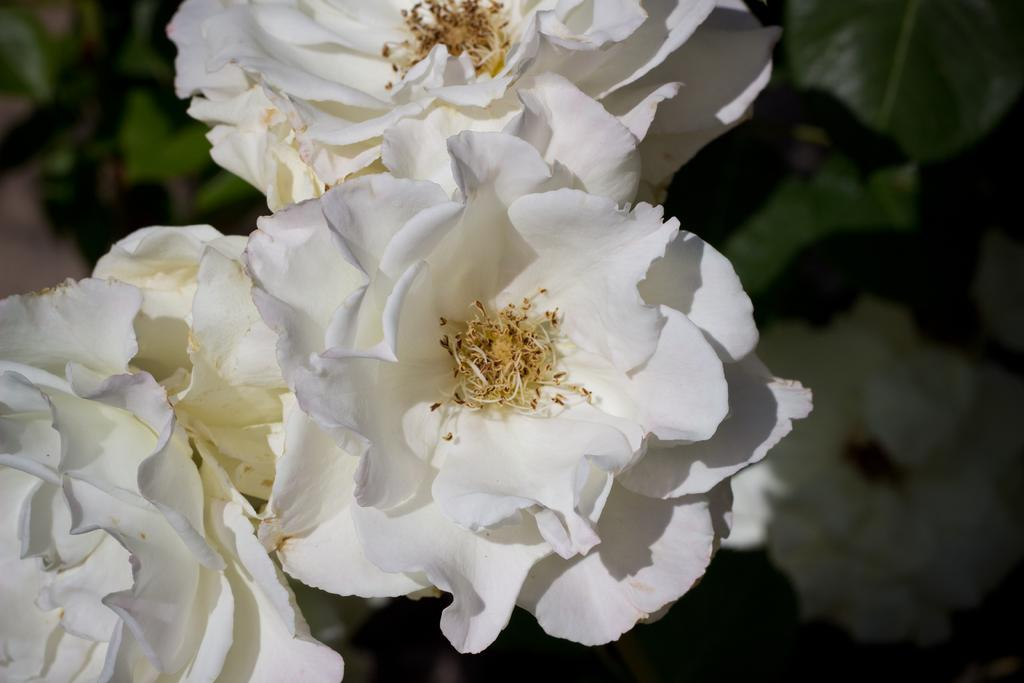What type of flowers are in the image? There are rose flowers in the image. What color are the rose flowers? The rose flowers are white in color. What can be seen in the background of the image? The background of the image is green. How is the background of the image depicted? The background is blurred. What hobbies are listed on the self in the image? There is no self or list of hobbies present in the image; it features white rose flowers with a green background. 